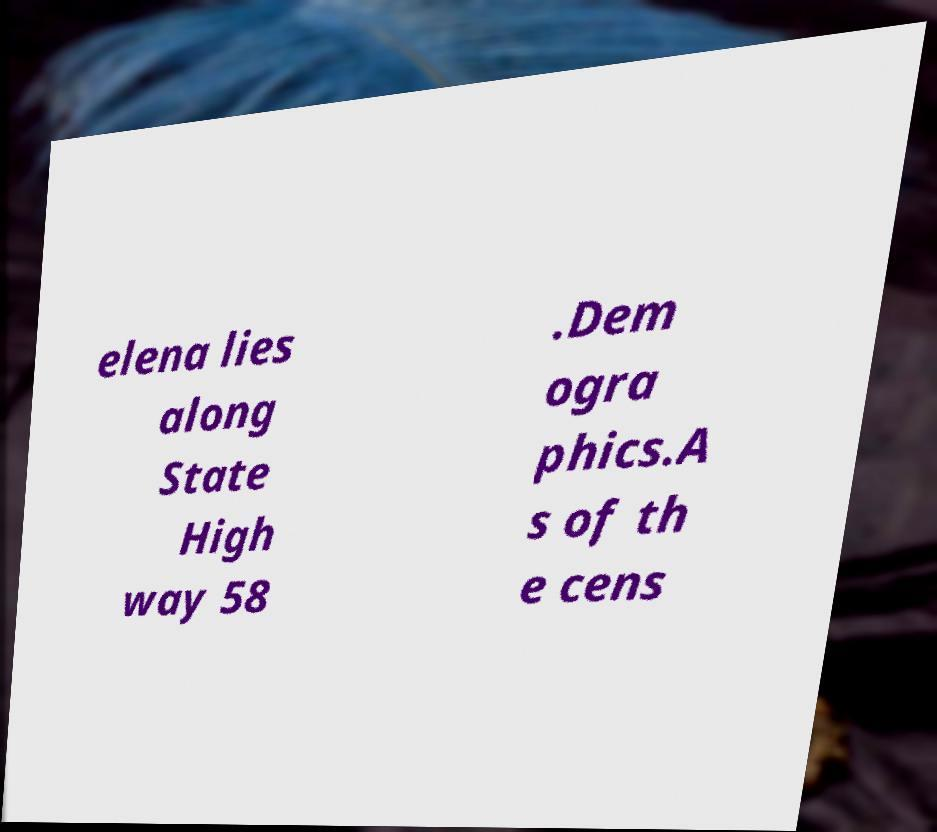Could you extract and type out the text from this image? elena lies along State High way 58 .Dem ogra phics.A s of th e cens 